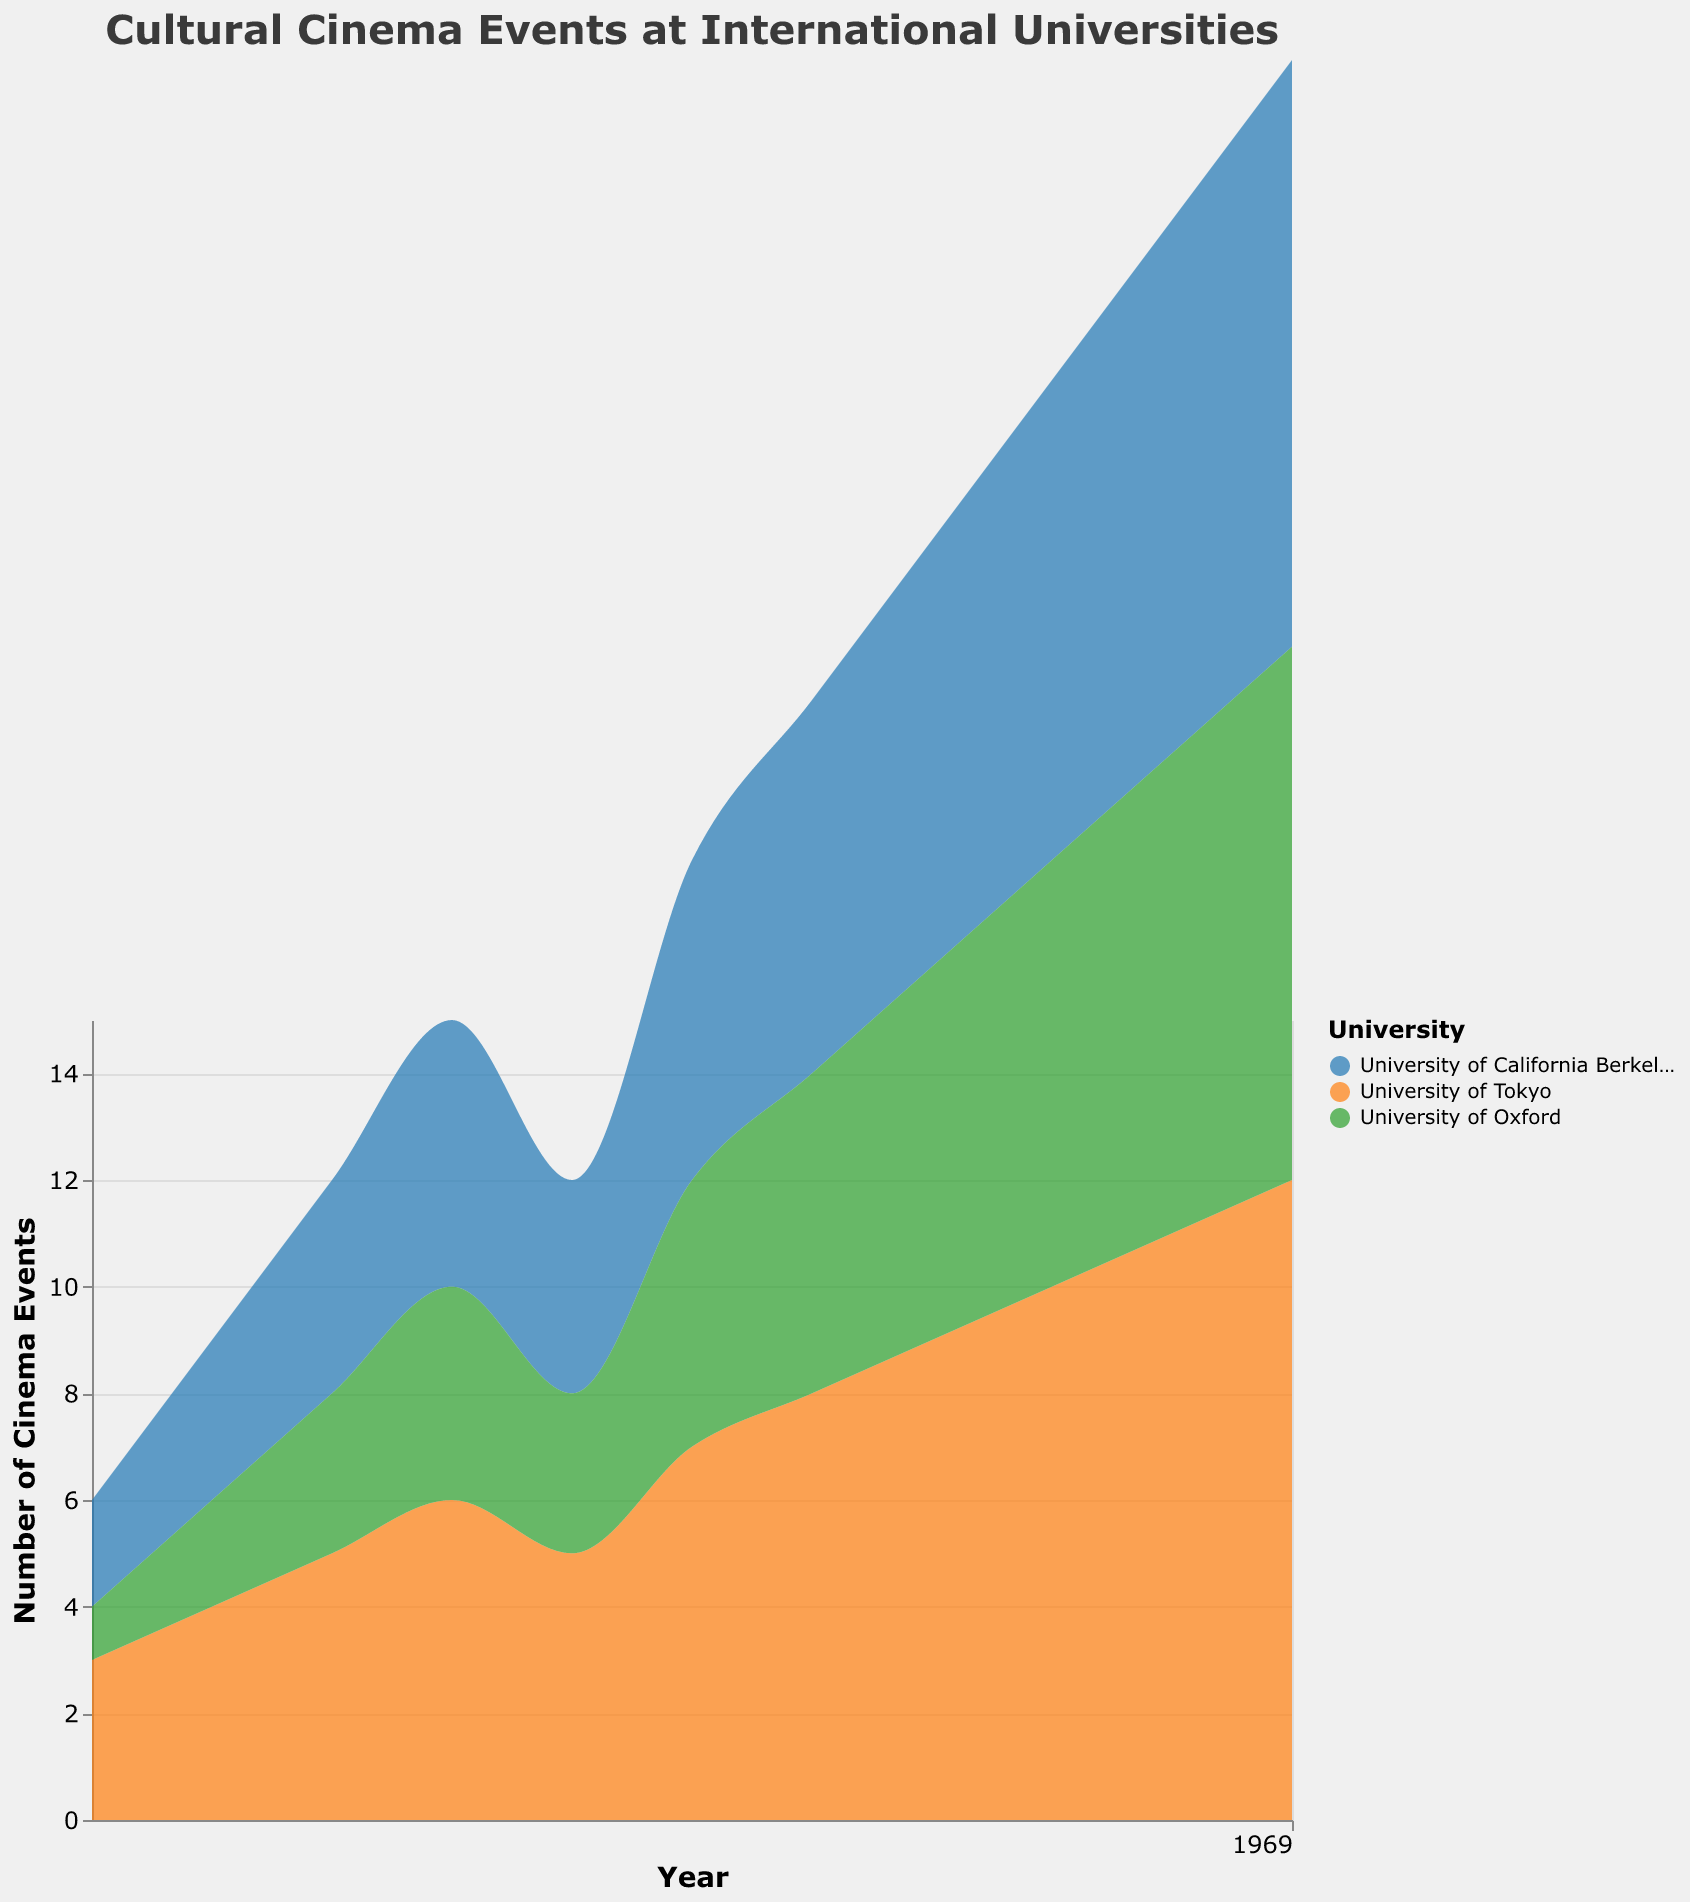What is the title of the figure? The title of the figure is displayed prominently at the top and is usually in a larger font for easy identification.
Answer: Cultural Cinema Events at International Universities Which university had the highest number of cinema events in 2018? Look for the highest peak or area in 2018 on the y-axis and check the corresponding color and legend to identify the university. The university with the orange color had the highest number of cinema events (University of Tokyo).
Answer: University of Tokyo How many cinema events were held at the University of Oxford in 2015? Locate the year 2015 on the x-axis, follow the corresponding value on the y-axis for the green area (representing the University of Oxford), and identify the count.
Answer: 3 What is the trend observed for cinema events at the University of California Berkeley from 2013 to 2023? Examine the blue area representing the University of California Berkeley over the years 2013 to 2023 to identify the trend.
Answer: Increasing What was the total number of cinema events across all universities in 2020? Sum the cinema event counts for all universities in 2020 by identifying the values for each university and adding them together: 8 (Berkeley) + 9 (Tokyo) + 7 (Oxford).
Answer: 24 Which university experienced the largest increase in cinema events from 2013 to 2023? Observe each colored area from 2013 to 2023 and identify the difference in values for each university. The University of Tokyo shows the greatest increase.
Answer: University of Tokyo How did the number of cinema events at the University of Oxford change between 2014 and 2016? Locate the values for the University of Oxford (green color) in 2014 and 2016 on the x-axis and compare them.
Answer: Increased by 2 (from 2 to 4) In which year did the University of California Berkeley have the same number of cinema events as the University of Tokyo? Find the overlapping or same height in the blue and orange areas and refer to the corresponding year on the x-axis.
Answer: 2017 What is the average number of cinema events held at the University of Tokyo over the last decade? Add up all the values for the University of Tokyo from 2013 to 2023 and divide by the number of years (11). Sum: 3 + 4 + 5 + 6 + 5 + 7 + 8 + 9 + 10 + 11 + 12 = 80. Average: 80 / 11 ≈ 7.27
Answer: Approximately 7.27 Compare the cinema event trend between the University of Oxford and the University of California Berkeley. Compare the green area for the University of Oxford and the blue area for the University of California Berkeley from 2013 to 2023. The University of California Berkeley's events show a consistent increase, while the University of Oxford also increases but at a slightly slower rate.
Answer: UC Berkeley increased more consistently than Oxford 